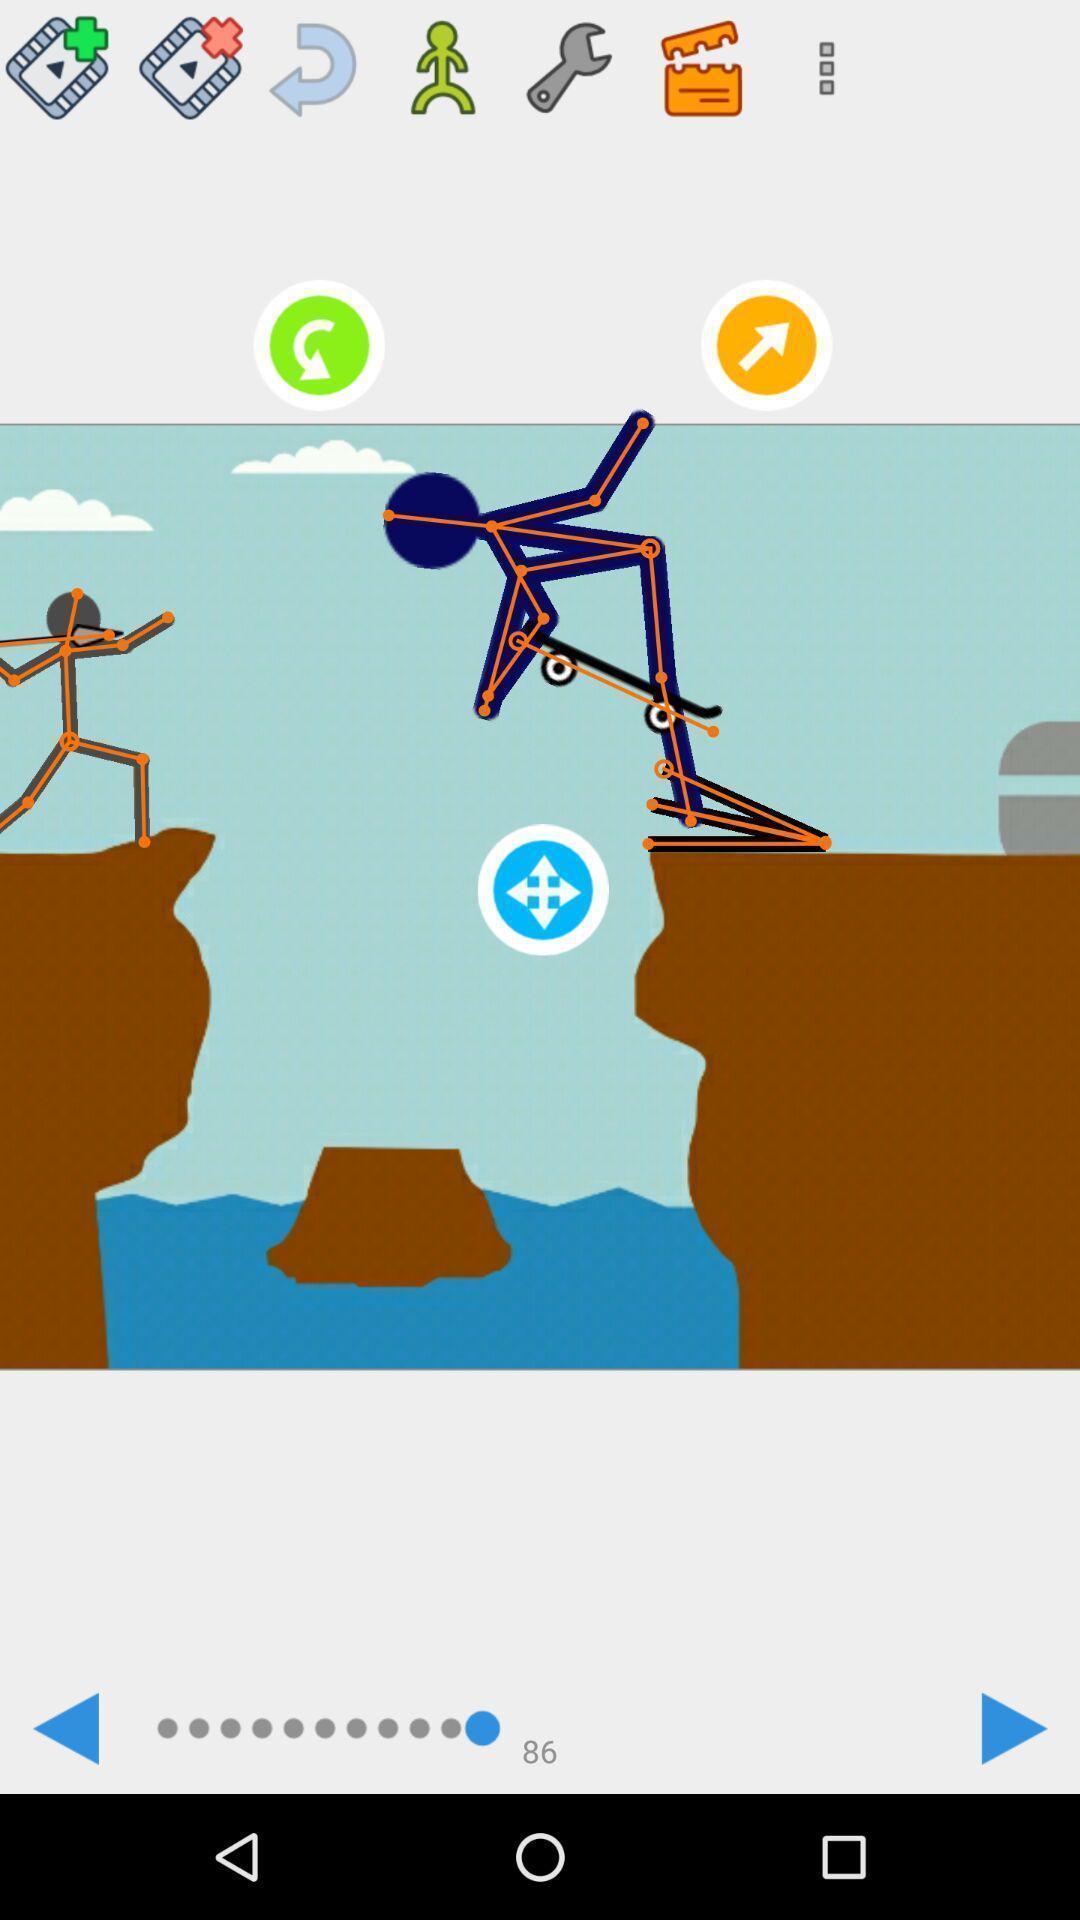Provide a textual representation of this image. Screen shows cartoon images in a gaming app. 